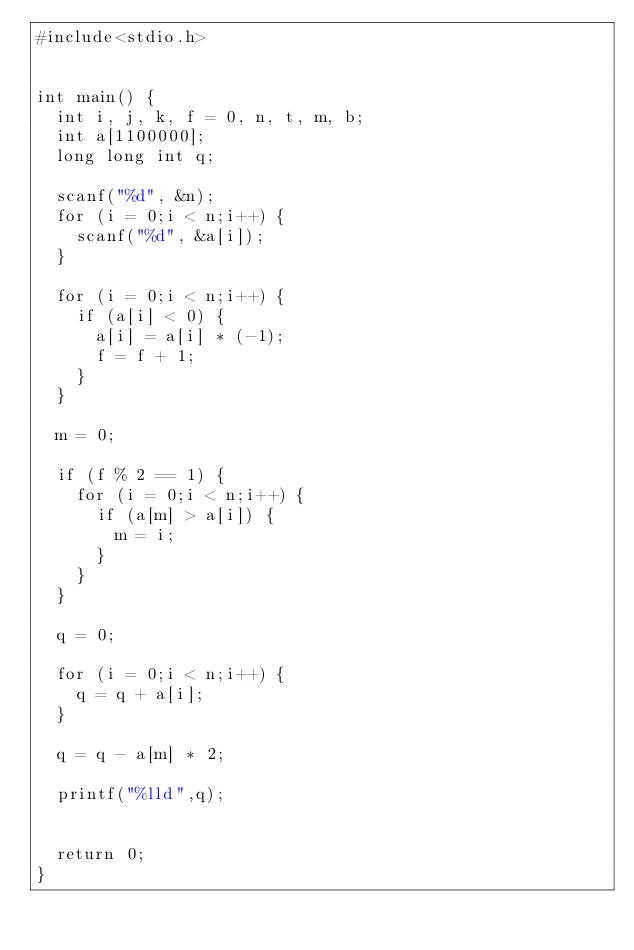Convert code to text. <code><loc_0><loc_0><loc_500><loc_500><_C_>#include<stdio.h>
 
 
int main() {
	int i, j, k, f = 0, n, t, m, b;
	int a[1100000];
	long long int q;
 
	scanf("%d", &n);
	for (i = 0;i < n;i++) {
		scanf("%d", &a[i]);
	}
 
	for (i = 0;i < n;i++) {
		if (a[i] < 0) {
			a[i] = a[i] * (-1);
			f = f + 1;
		}
	}
 
	m = 0;
 
	if (f % 2 == 1) {
		for (i = 0;i < n;i++) {
			if (a[m] > a[i]) {
				m = i;
			}
		}
	}
	
	q = 0;
	
	for (i = 0;i < n;i++) {
		q = q + a[i];
	}
 
	q = q - a[m] * 2;
 
	printf("%lld",q);
 
 
	return 0;
}</code> 